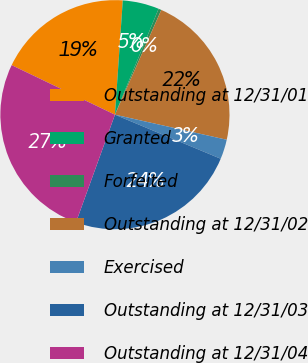<chart> <loc_0><loc_0><loc_500><loc_500><pie_chart><fcel>Outstanding at 12/31/01<fcel>Granted<fcel>Forfeited<fcel>Outstanding at 12/31/02<fcel>Exercised<fcel>Outstanding at 12/31/03<fcel>Outstanding at 12/31/04<nl><fcel>18.97%<fcel>5.13%<fcel>0.41%<fcel>21.88%<fcel>2.77%<fcel>24.24%<fcel>26.59%<nl></chart> 